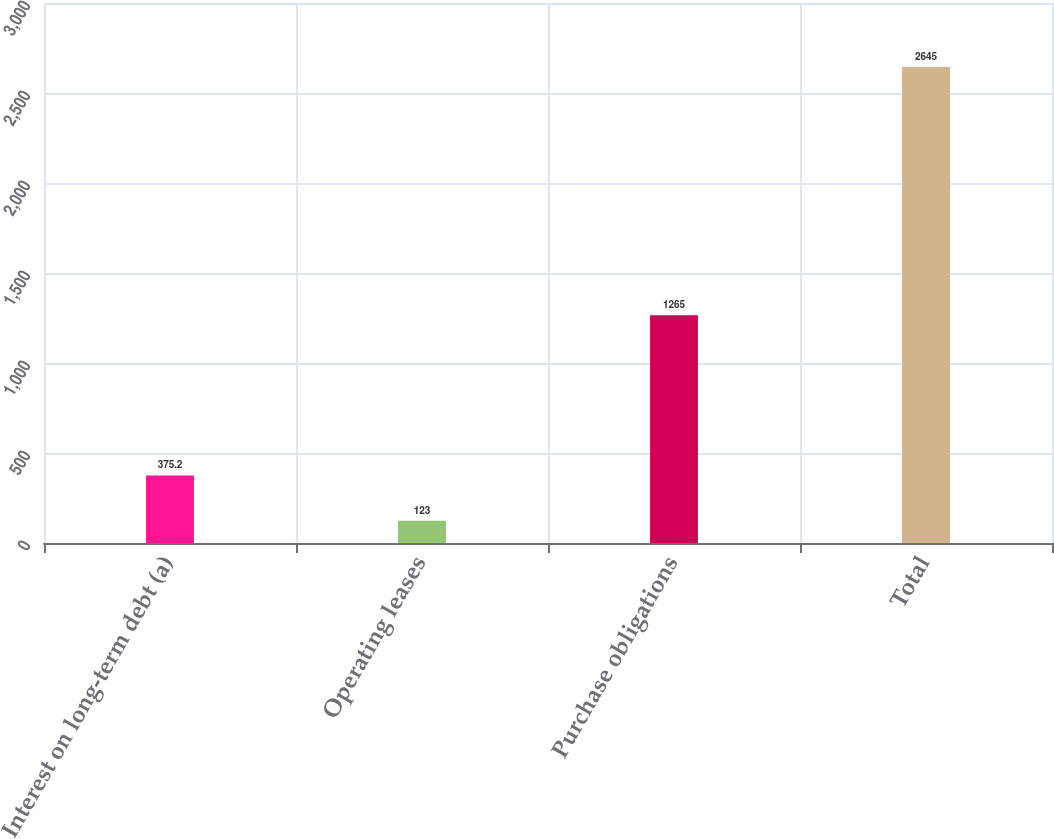<chart> <loc_0><loc_0><loc_500><loc_500><bar_chart><fcel>Interest on long-term debt (a)<fcel>Operating leases<fcel>Purchase obligations<fcel>Total<nl><fcel>375.2<fcel>123<fcel>1265<fcel>2645<nl></chart> 